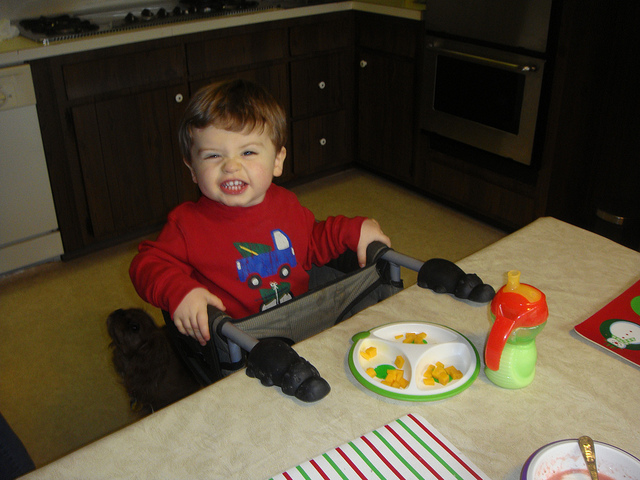<image>What kind of meat is being served? I don't know what kind of meat is being served. It might be chicken or hot dog, or there might be no meat at all. What kind of meat is being served? I am not sure what kind of meat is being served. It could be chicken, hot dog or none at all. 